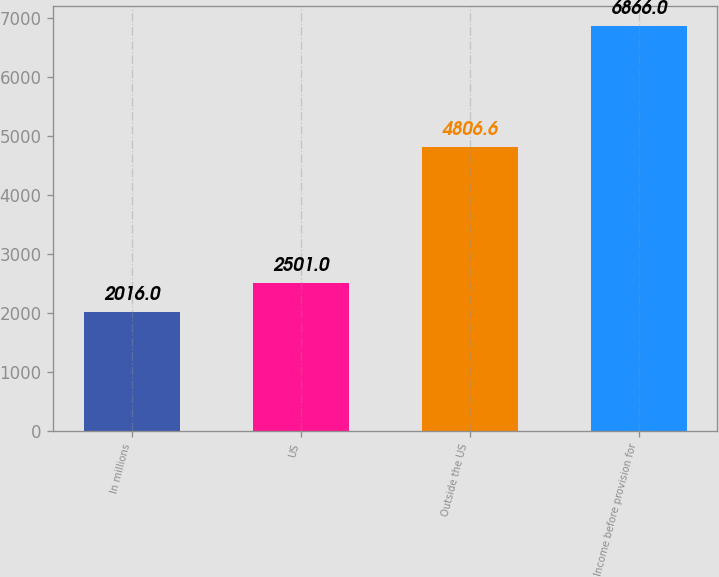Convert chart to OTSL. <chart><loc_0><loc_0><loc_500><loc_500><bar_chart><fcel>In millions<fcel>US<fcel>Outside the US<fcel>Income before provision for<nl><fcel>2016<fcel>2501<fcel>4806.6<fcel>6866<nl></chart> 